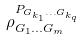Convert formula to latex. <formula><loc_0><loc_0><loc_500><loc_500>\rho _ { G _ { 1 } \dots G _ { m } } ^ { P _ { G _ { k _ { 1 } } \dots G _ { k _ { q } } } }</formula> 